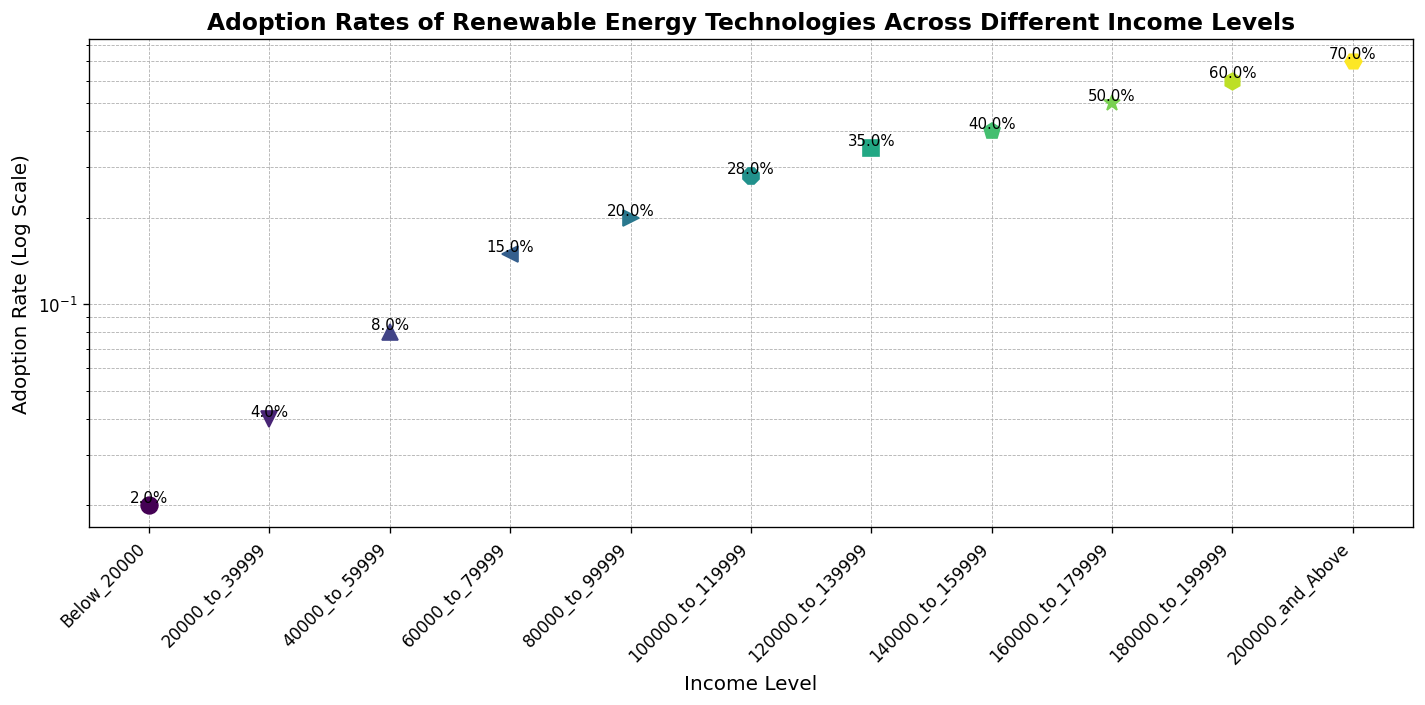Which income level has the highest adoption rate? The figure shows the adoption rates of renewable energy technologies across various income levels. By visually inspecting the points and the associated text labels, the income level with an adoption rate of 0.70 (70%) is the highest.
Answer: 200000_and_Above Which income level has the lowest adoption rate? By examining the points and their labels in the figure, the income level with an adoption rate of 0.02 (2%) is the lowest.
Answer: Below_20000 What is the adoption rate for the income level of 60000_to_79999? To find this, identify the point corresponding to the income level 60000_to_79999. The text label next to this point shows an adoption rate of 15%.
Answer: 0.15 How many income levels have an adoption rate of 20% or more? Counting the points and labels that show adoption rates equal to or above 0.20 (20%), there are six income levels: 80000_to_99999, 100000_to_119999, 120000_to_139999, 140000_to_159999, 160000_to_179999, 180000_to_199999, 200000_and_Above.
Answer: 7 Which income levels have an adoption rate higher than 0.28 but lower than 0.50? By examining the points and labels, the income levels with adoption rates between 0.28 and 0.50 are 120000_to_139999 (0.35) and 140000_to_159999 (0.40).
Answer: 120000_to_139999, 140000_to_159999 What is the difference in adoption rates between the income levels 40000_to_59999 and 140000_to_159999? Find the adoption rates for both income levels: 40000_to_59999 has 0.08 and 140000_to_159999 has 0.40. The difference is 0.40 - 0.08.
Answer: 0.32 How does the adoption rate change as the income level increases from Below_20000 to 200000_and_Above? By observing the progression of adoption rates in the figure, it can be seen that the adoption rate increases with income, starting from 0.02 for Below_20000 and reaching 0.70 for 200000_and_Above.
Answer: Increases What is the average adoption rate for income levels below 100000? The income levels under 100000 along with their adoption rates are Below_20000 (0.02), 20000_to_39999 (0.04), 40000_to_59999 (0.08), 60000_to_79999 (0.15), 80000_to_99999 (0.20). The sum of these rates is 0.49. There are 5 levels, so the average is 0.49 / 5.
Answer: 0.098 Compare the adoption rates between the income levels 80000_to_99999 and 120000_to_139999. Which is higher? The figure shows the adoption rate for 80000_to_99999 is 0.20, and for 120000_to_139999 it is 0.35. Thus, the adoption rate for 120000_to_139999 is higher.
Answer: 120000_to_139999 If we combine the adoption rates of 60000_to_79999 and 160000_to_179999, what do we get? The adoption rate for 60000_to_79999 is 0.15 and for 160000_to_179999 is 0.50. Adding these rates together: 0.15 + 0.50 = 0.65.
Answer: 0.65 